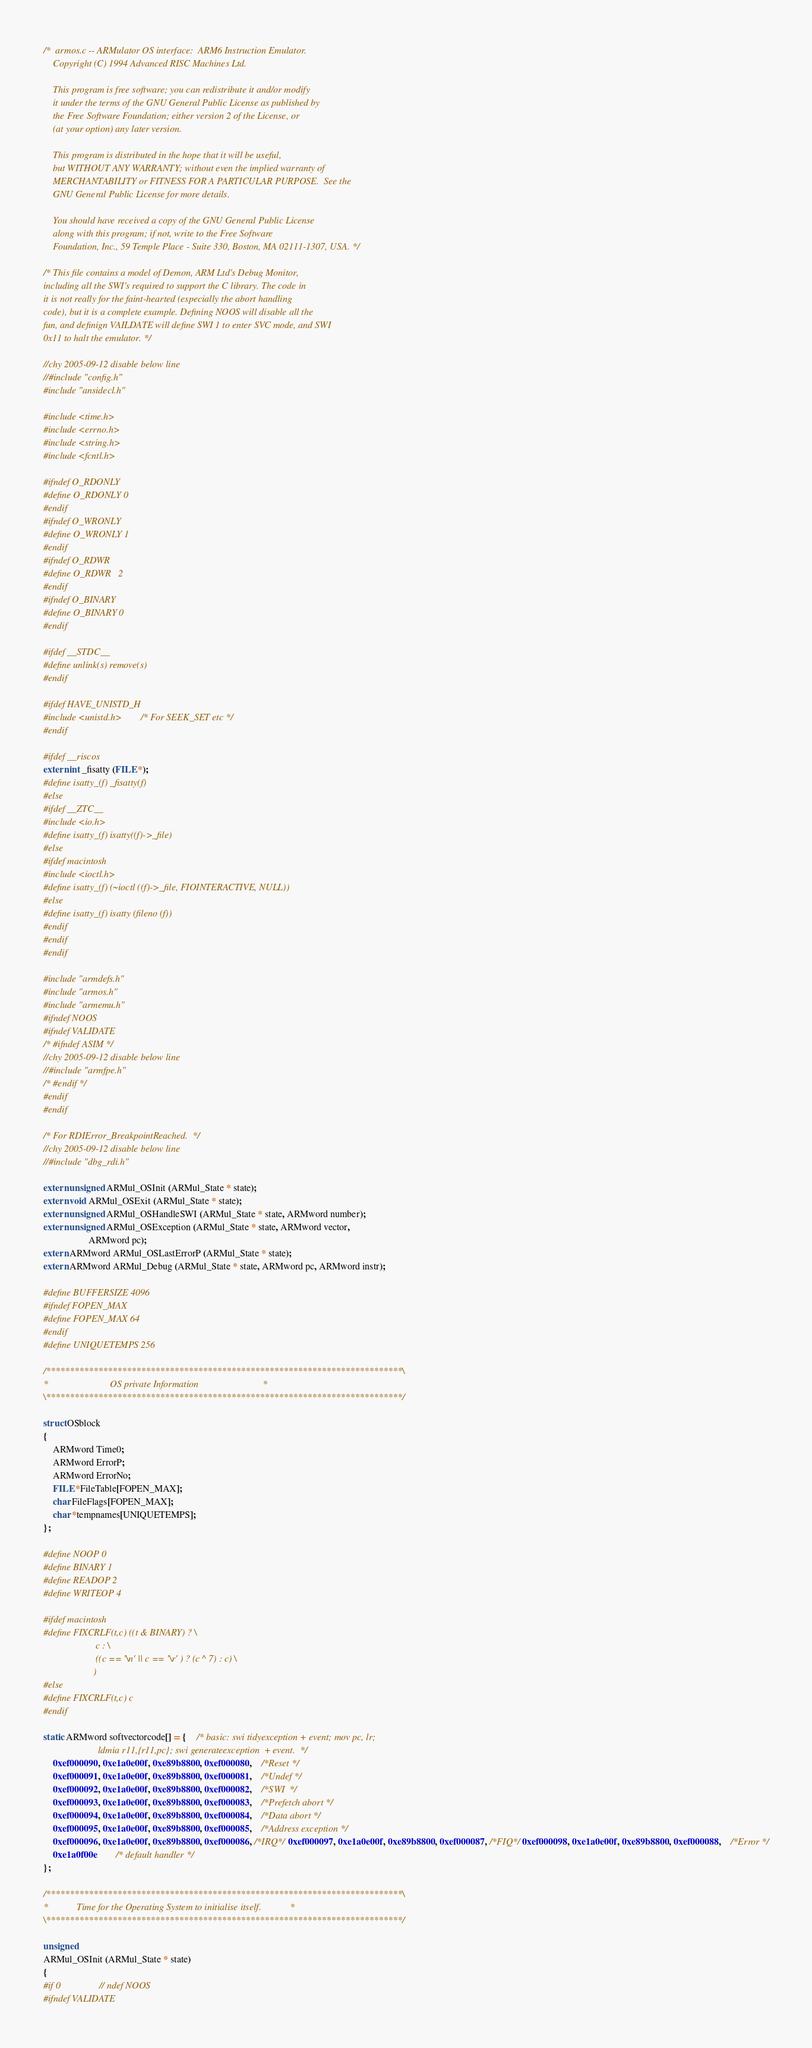Convert code to text. <code><loc_0><loc_0><loc_500><loc_500><_C_>/*  armos.c -- ARMulator OS interface:  ARM6 Instruction Emulator.
    Copyright (C) 1994 Advanced RISC Machines Ltd.
 
    This program is free software; you can redistribute it and/or modify
    it under the terms of the GNU General Public License as published by
    the Free Software Foundation; either version 2 of the License, or
    (at your option) any later version.
 
    This program is distributed in the hope that it will be useful,
    but WITHOUT ANY WARRANTY; without even the implied warranty of
    MERCHANTABILITY or FITNESS FOR A PARTICULAR PURPOSE.  See the
    GNU General Public License for more details.
 
    You should have received a copy of the GNU General Public License
    along with this program; if not, write to the Free Software
    Foundation, Inc., 59 Temple Place - Suite 330, Boston, MA 02111-1307, USA. */

/* This file contains a model of Demon, ARM Ltd's Debug Monitor,
including all the SWI's required to support the C library. The code in
it is not really for the faint-hearted (especially the abort handling
code), but it is a complete example. Defining NOOS will disable all the
fun, and definign VAILDATE will define SWI 1 to enter SVC mode, and SWI
0x11 to halt the emulator. */

//chy 2005-09-12 disable below line
//#include "config.h"
#include "ansidecl.h"

#include <time.h>
#include <errno.h>
#include <string.h>
#include <fcntl.h>

#ifndef O_RDONLY
#define O_RDONLY 0
#endif
#ifndef O_WRONLY
#define O_WRONLY 1
#endif
#ifndef O_RDWR
#define O_RDWR   2
#endif
#ifndef O_BINARY
#define O_BINARY 0
#endif

#ifdef __STDC__
#define unlink(s) remove(s)
#endif

#ifdef HAVE_UNISTD_H
#include <unistd.h>		/* For SEEK_SET etc */
#endif

#ifdef __riscos
extern int _fisatty (FILE *);
#define isatty_(f) _fisatty(f)
#else
#ifdef __ZTC__
#include <io.h>
#define isatty_(f) isatty((f)->_file)
#else
#ifdef macintosh
#include <ioctl.h>
#define isatty_(f) (~ioctl ((f)->_file, FIOINTERACTIVE, NULL))
#else
#define isatty_(f) isatty (fileno (f))
#endif
#endif
#endif

#include "armdefs.h"
#include "armos.h"
#include "armemu.h"
#ifndef NOOS
#ifndef VALIDATE
/* #ifndef ASIM */
//chy 2005-09-12 disable below line
//#include "armfpe.h"
/* #endif */
#endif
#endif

/* For RDIError_BreakpointReached.  */
//chy 2005-09-12 disable below line
//#include "dbg_rdi.h"

extern unsigned ARMul_OSInit (ARMul_State * state);
extern void ARMul_OSExit (ARMul_State * state);
extern unsigned ARMul_OSHandleSWI (ARMul_State * state, ARMword number);
extern unsigned ARMul_OSException (ARMul_State * state, ARMword vector,
				   ARMword pc);
extern ARMword ARMul_OSLastErrorP (ARMul_State * state);
extern ARMword ARMul_Debug (ARMul_State * state, ARMword pc, ARMword instr);

#define BUFFERSIZE 4096
#ifndef FOPEN_MAX
#define FOPEN_MAX 64
#endif
#define UNIQUETEMPS 256

/***************************************************************************\
*                          OS private Information                           *
\***************************************************************************/

struct OSblock
{
	ARMword Time0;
	ARMword ErrorP;
	ARMword ErrorNo;
	FILE *FileTable[FOPEN_MAX];
	char FileFlags[FOPEN_MAX];
	char *tempnames[UNIQUETEMPS];
};

#define NOOP 0
#define BINARY 1
#define READOP 2
#define WRITEOP 4

#ifdef macintosh
#define FIXCRLF(t,c) ((t & BINARY) ? \
                      c : \
                      ((c == '\n' || c == '\r' ) ? (c ^ 7) : c) \
                     )
#else
#define FIXCRLF(t,c) c
#endif

static ARMword softvectorcode[] = {	/* basic: swi tidyexception + event; mov pc, lr;
					   ldmia r11,{r11,pc}; swi generateexception  + event.  */
	0xef000090, 0xe1a0e00f, 0xe89b8800, 0xef000080,	/*Reset */
	0xef000091, 0xe1a0e00f, 0xe89b8800, 0xef000081,	/*Undef */
	0xef000092, 0xe1a0e00f, 0xe89b8800, 0xef000082,	/*SWI  */
	0xef000093, 0xe1a0e00f, 0xe89b8800, 0xef000083,	/*Prefetch abort */
	0xef000094, 0xe1a0e00f, 0xe89b8800, 0xef000084,	/*Data abort */
	0xef000095, 0xe1a0e00f, 0xe89b8800, 0xef000085,	/*Address exception */
	0xef000096, 0xe1a0e00f, 0xe89b8800, 0xef000086, /*IRQ*/ 0xef000097, 0xe1a0e00f, 0xe89b8800, 0xef000087, /*FIQ*/ 0xef000098, 0xe1a0e00f, 0xe89b8800, 0xef000088,	/*Error */
	0xe1a0f00e		/* default handler */
};

/***************************************************************************\
*            Time for the Operating System to initialise itself.            *
\***************************************************************************/

unsigned
ARMul_OSInit (ARMul_State * state)
{
#if 0				// ndef NOOS
#ifndef VALIDATE</code> 